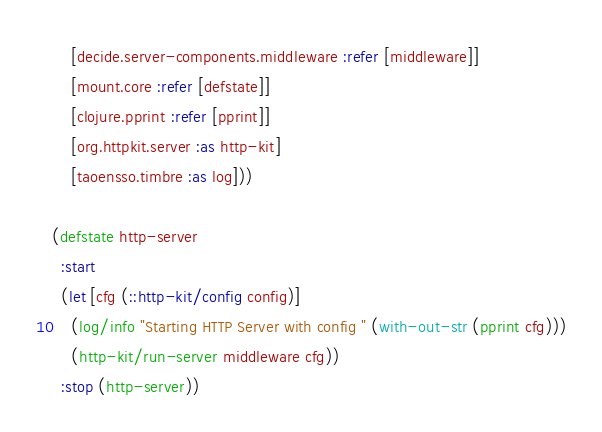Convert code to text. <code><loc_0><loc_0><loc_500><loc_500><_Clojure_>    [decide.server-components.middleware :refer [middleware]]
    [mount.core :refer [defstate]]
    [clojure.pprint :refer [pprint]]
    [org.httpkit.server :as http-kit]
    [taoensso.timbre :as log]))

(defstate http-server
  :start
  (let [cfg (::http-kit/config config)]
    (log/info "Starting HTTP Server with config " (with-out-str (pprint cfg)))
    (http-kit/run-server middleware cfg))
  :stop (http-server))
</code> 